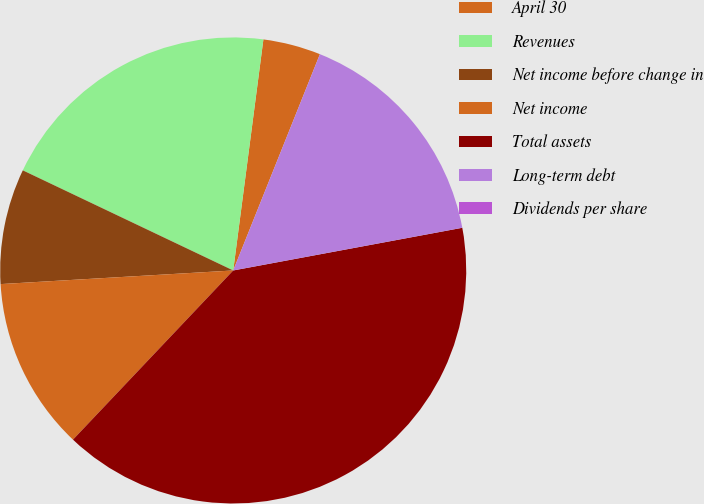Convert chart. <chart><loc_0><loc_0><loc_500><loc_500><pie_chart><fcel>April 30<fcel>Revenues<fcel>Net income before change in<fcel>Net income<fcel>Total assets<fcel>Long-term debt<fcel>Dividends per share<nl><fcel>4.0%<fcel>20.0%<fcel>8.0%<fcel>12.0%<fcel>40.0%<fcel>16.0%<fcel>0.0%<nl></chart> 